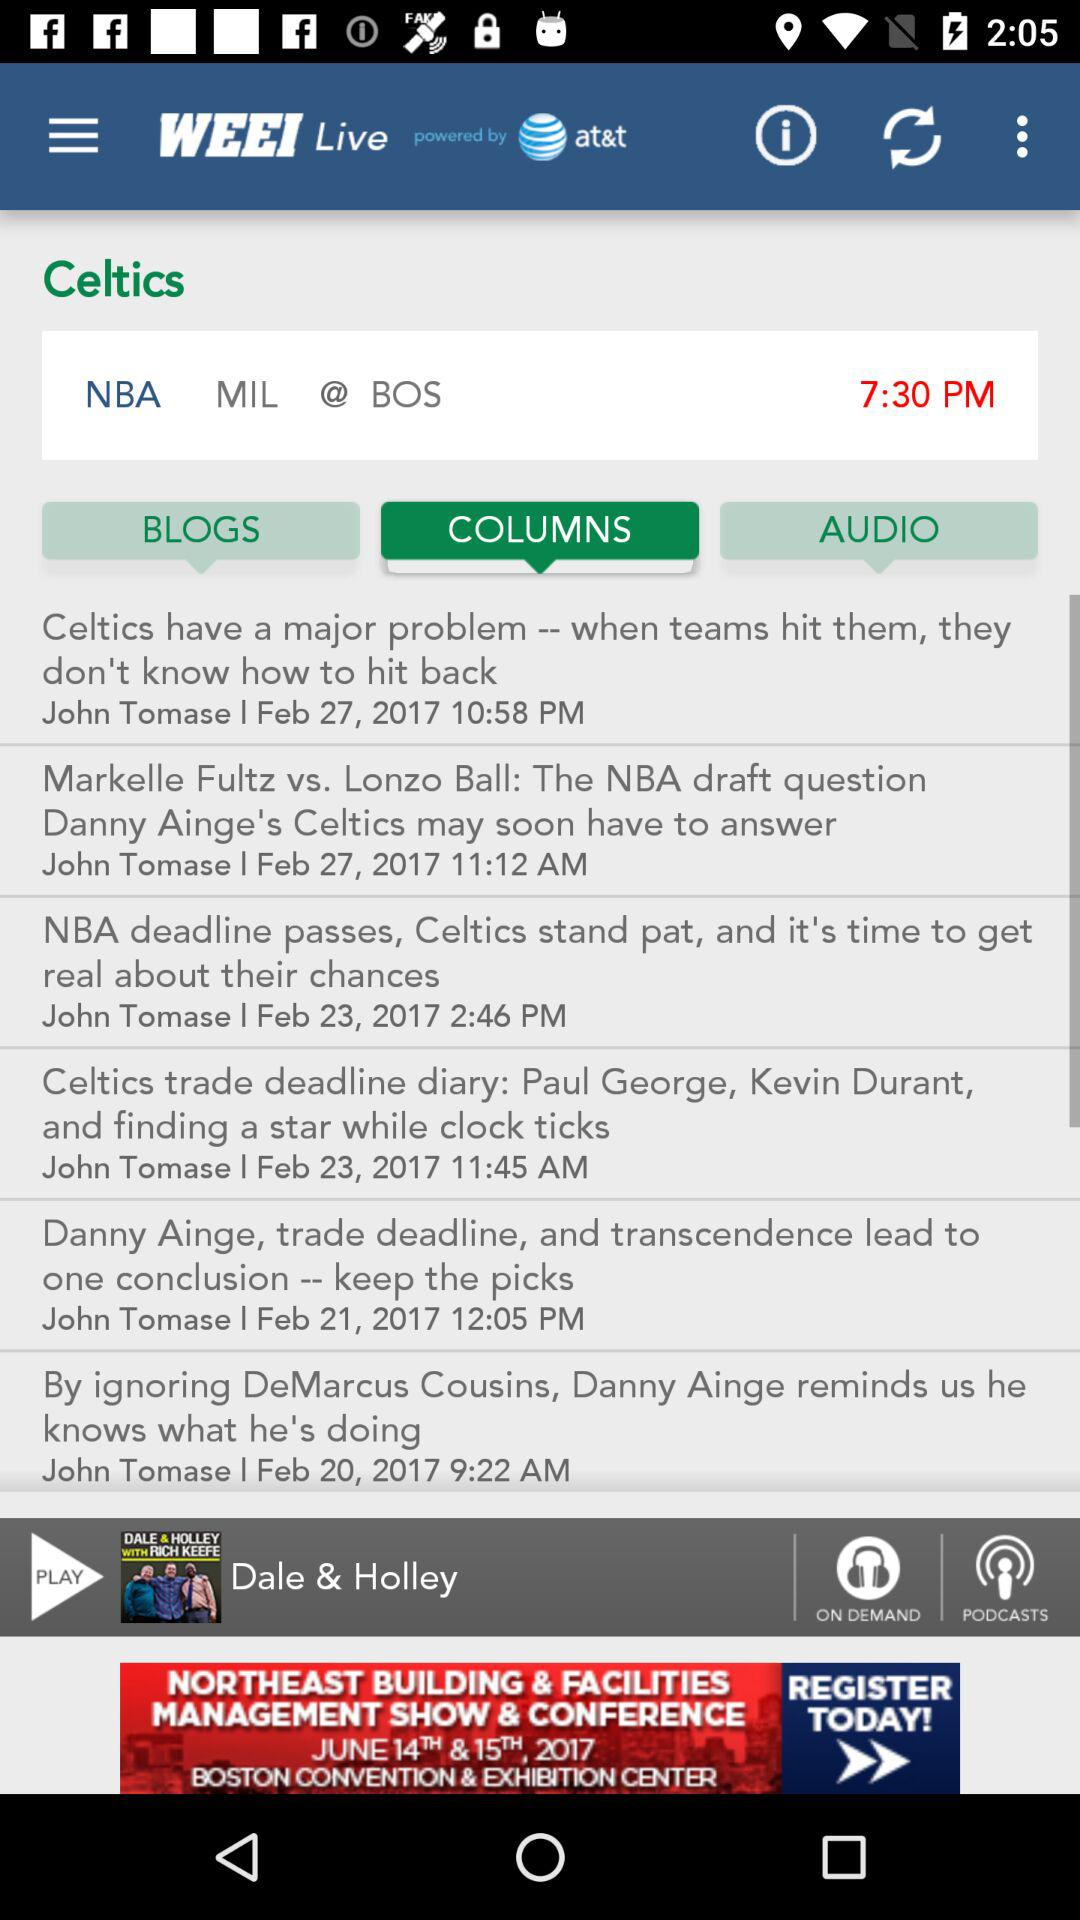Which tab is selected? The selected tab is "COLUMNS". 